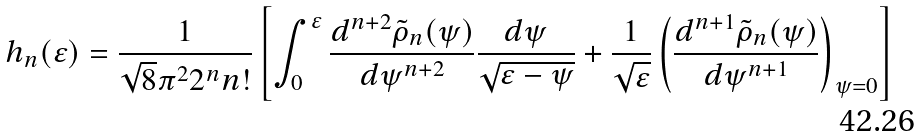<formula> <loc_0><loc_0><loc_500><loc_500>h _ { n } ( \varepsilon ) = \frac { 1 } { \sqrt { 8 } \pi ^ { 2 } 2 ^ { n } n ! } \left [ \int _ { 0 } ^ { \varepsilon } \frac { d ^ { n + 2 } \tilde { \rho } _ { n } ( \psi ) } { d \psi ^ { n + 2 } } \frac { d \psi } { \sqrt { \varepsilon - \psi } } + \frac { 1 } { \sqrt { \varepsilon } } \left ( \frac { d ^ { n + 1 } \tilde { \rho } _ { n } ( \psi ) } { d \psi ^ { n + 1 } } \right ) _ { \psi = 0 } \right ]</formula> 